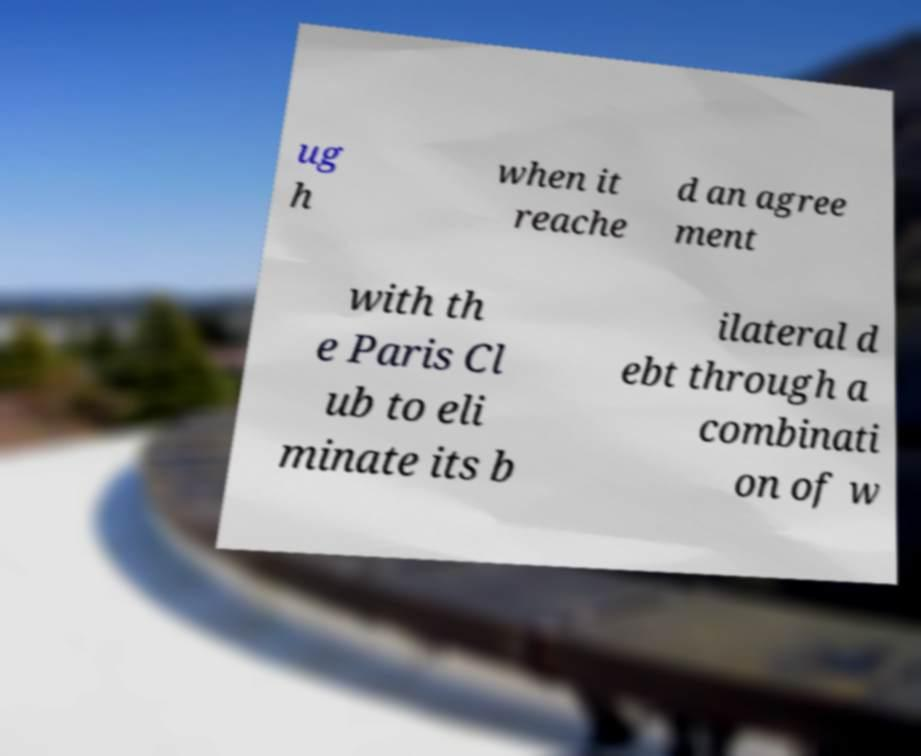There's text embedded in this image that I need extracted. Can you transcribe it verbatim? ug h when it reache d an agree ment with th e Paris Cl ub to eli minate its b ilateral d ebt through a combinati on of w 